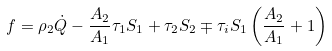Convert formula to latex. <formula><loc_0><loc_0><loc_500><loc_500>f = \rho _ { 2 } \dot { Q } - \frac { A _ { 2 } } { A _ { 1 } } \tau _ { 1 } S _ { 1 } + \tau _ { 2 } S _ { 2 } \mp \tau _ { i } S _ { 1 } \left ( \frac { A _ { 2 } } { A _ { 1 } } + 1 \right )</formula> 